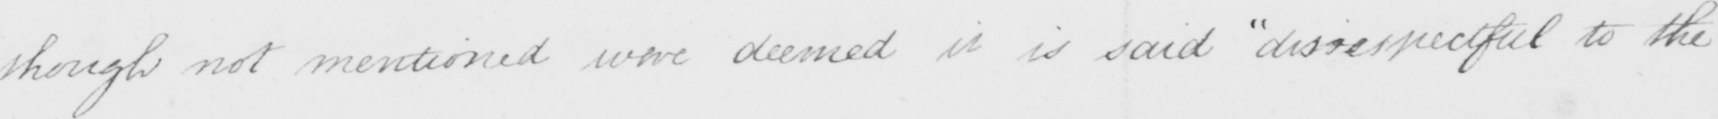Please transcribe the handwritten text in this image. though not mentioned were deemed  " disrespectful to the 